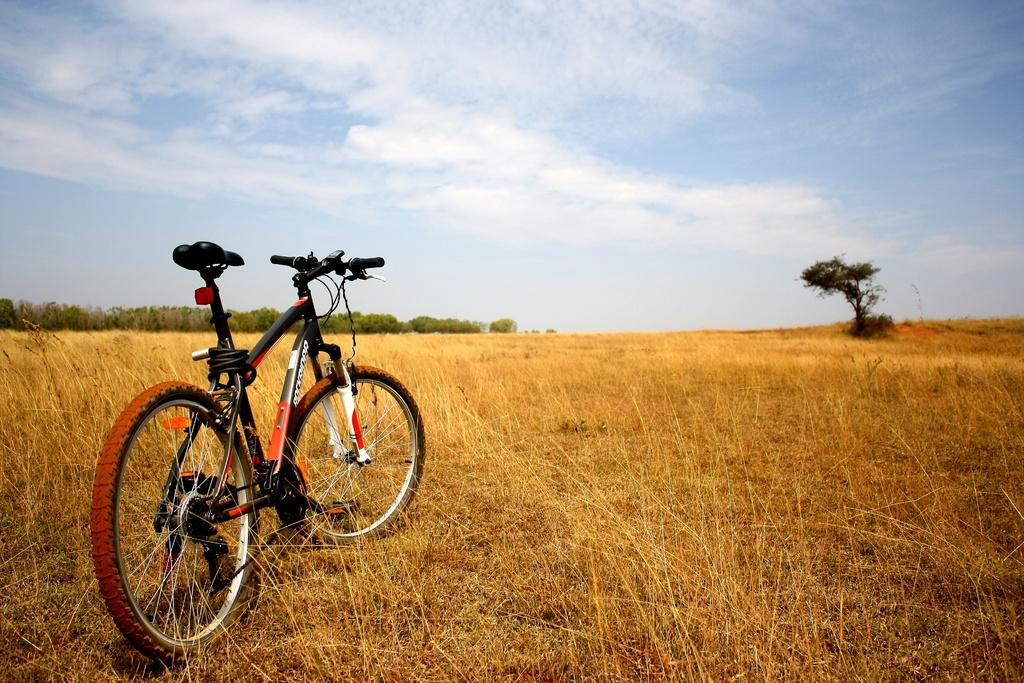What is the main object in the image? There is a bicycle in the image. What type of terrain is visible in the image? There is grass visible in the image. What can be seen in the background of the image? There are trees and farmland in the background of the image. What is visible at the top of the image? The sky is visible at the top of the image, and clouds are present in the sky. Where is the mom in the image? There is no mom present in the image. What type of drain is visible in the image? There is no drain present in the image. 